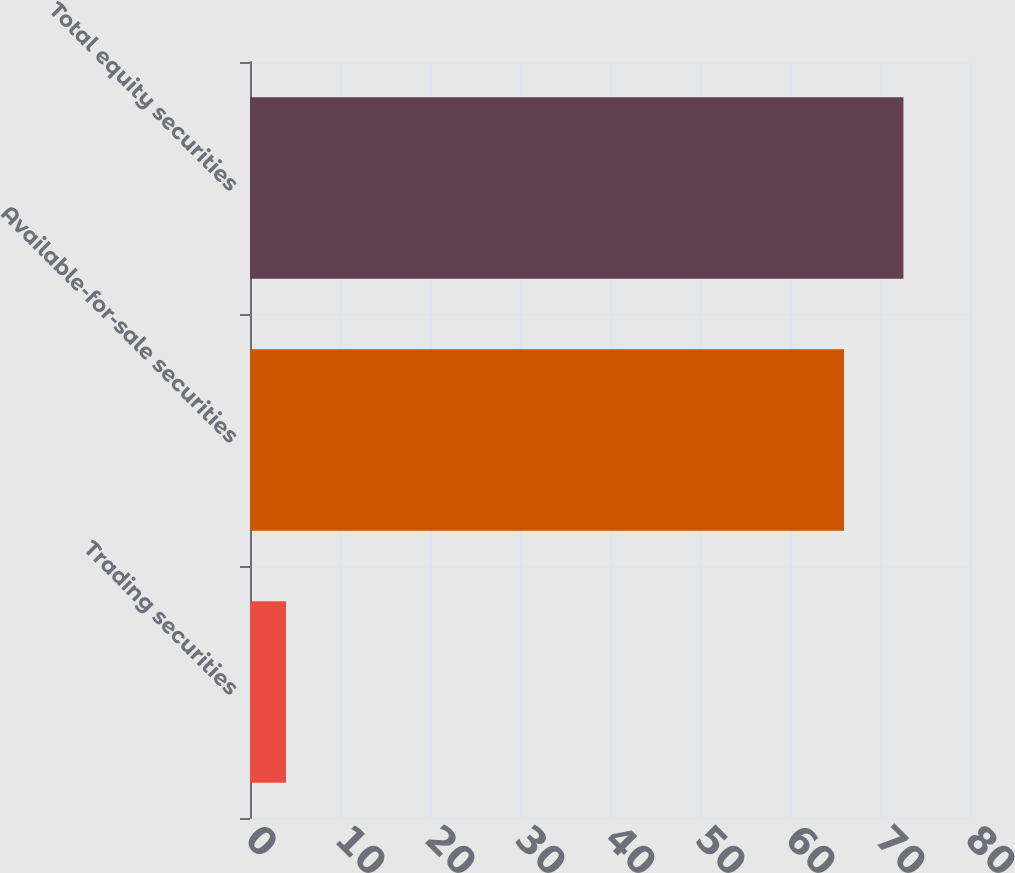Convert chart. <chart><loc_0><loc_0><loc_500><loc_500><bar_chart><fcel>Trading securities<fcel>Available-for-sale securities<fcel>Total equity securities<nl><fcel>4<fcel>66<fcel>72.6<nl></chart> 